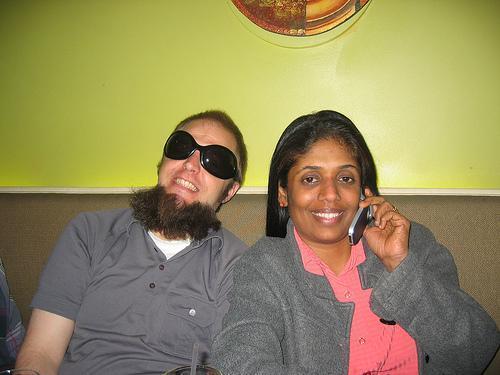How many people in picture?
Give a very brief answer. 2. 